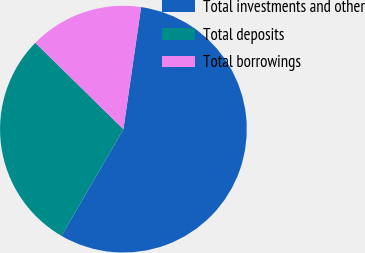<chart> <loc_0><loc_0><loc_500><loc_500><pie_chart><fcel>Total investments and other<fcel>Total deposits<fcel>Total borrowings<nl><fcel>56.07%<fcel>28.97%<fcel>14.95%<nl></chart> 